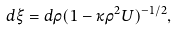Convert formula to latex. <formula><loc_0><loc_0><loc_500><loc_500>d \xi = d \rho ( 1 - \kappa \rho ^ { 2 } U ) ^ { - 1 / 2 } ,</formula> 